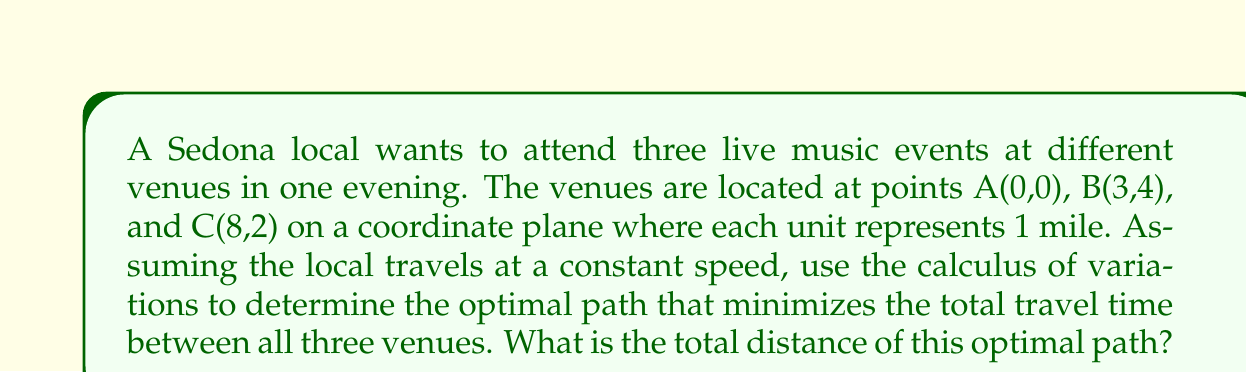Help me with this question. To solve this problem, we'll use the principle of least action from the calculus of variations. The optimal path between two points in a plane is always a straight line. Therefore, we need to find the shortest path that connects all three points.

1. First, let's calculate the distances between each pair of points:

   AB = $\sqrt{(3-0)^2 + (4-0)^2} = \sqrt{9 + 16} = 5$ miles
   BC = $\sqrt{(8-3)^2 + (2-4)^2} = \sqrt{25 + 4} = \sqrt{29}$ miles
   AC = $\sqrt{(8-0)^2 + (2-0)^2} = \sqrt{64 + 4} = \sqrt{68}$ miles

2. Now, we have three possible routes:
   a) A → B → C
   b) A → C → B
   c) B → A → C

3. Let's calculate the total distance for each route:
   a) A → B → C: $5 + \sqrt{29} \approx 10.39$ miles
   b) A → C → B: $\sqrt{68} + 5 \approx 13.25$ miles
   c) B → A → C: $5 + \sqrt{68} \approx 13.25$ miles

4. The route with the shortest total distance is A → B → C.

5. To verify this result mathematically, we can use the triangle inequality theorem, which states that the sum of the lengths of any two sides of a triangle must be greater than the length of the remaining side.

   In this case: AB + BC < AC + AB and AB + BC < AC + BC

   $5 + \sqrt{29} < \sqrt{68} + 5$ and $5 + \sqrt{29} < \sqrt{68} + \sqrt{29}$

   Both inequalities hold true, confirming that A → B → C is indeed the optimal path.
Answer: The optimal path is A → B → C, with a total distance of $5 + \sqrt{29} \approx 10.39$ miles. 